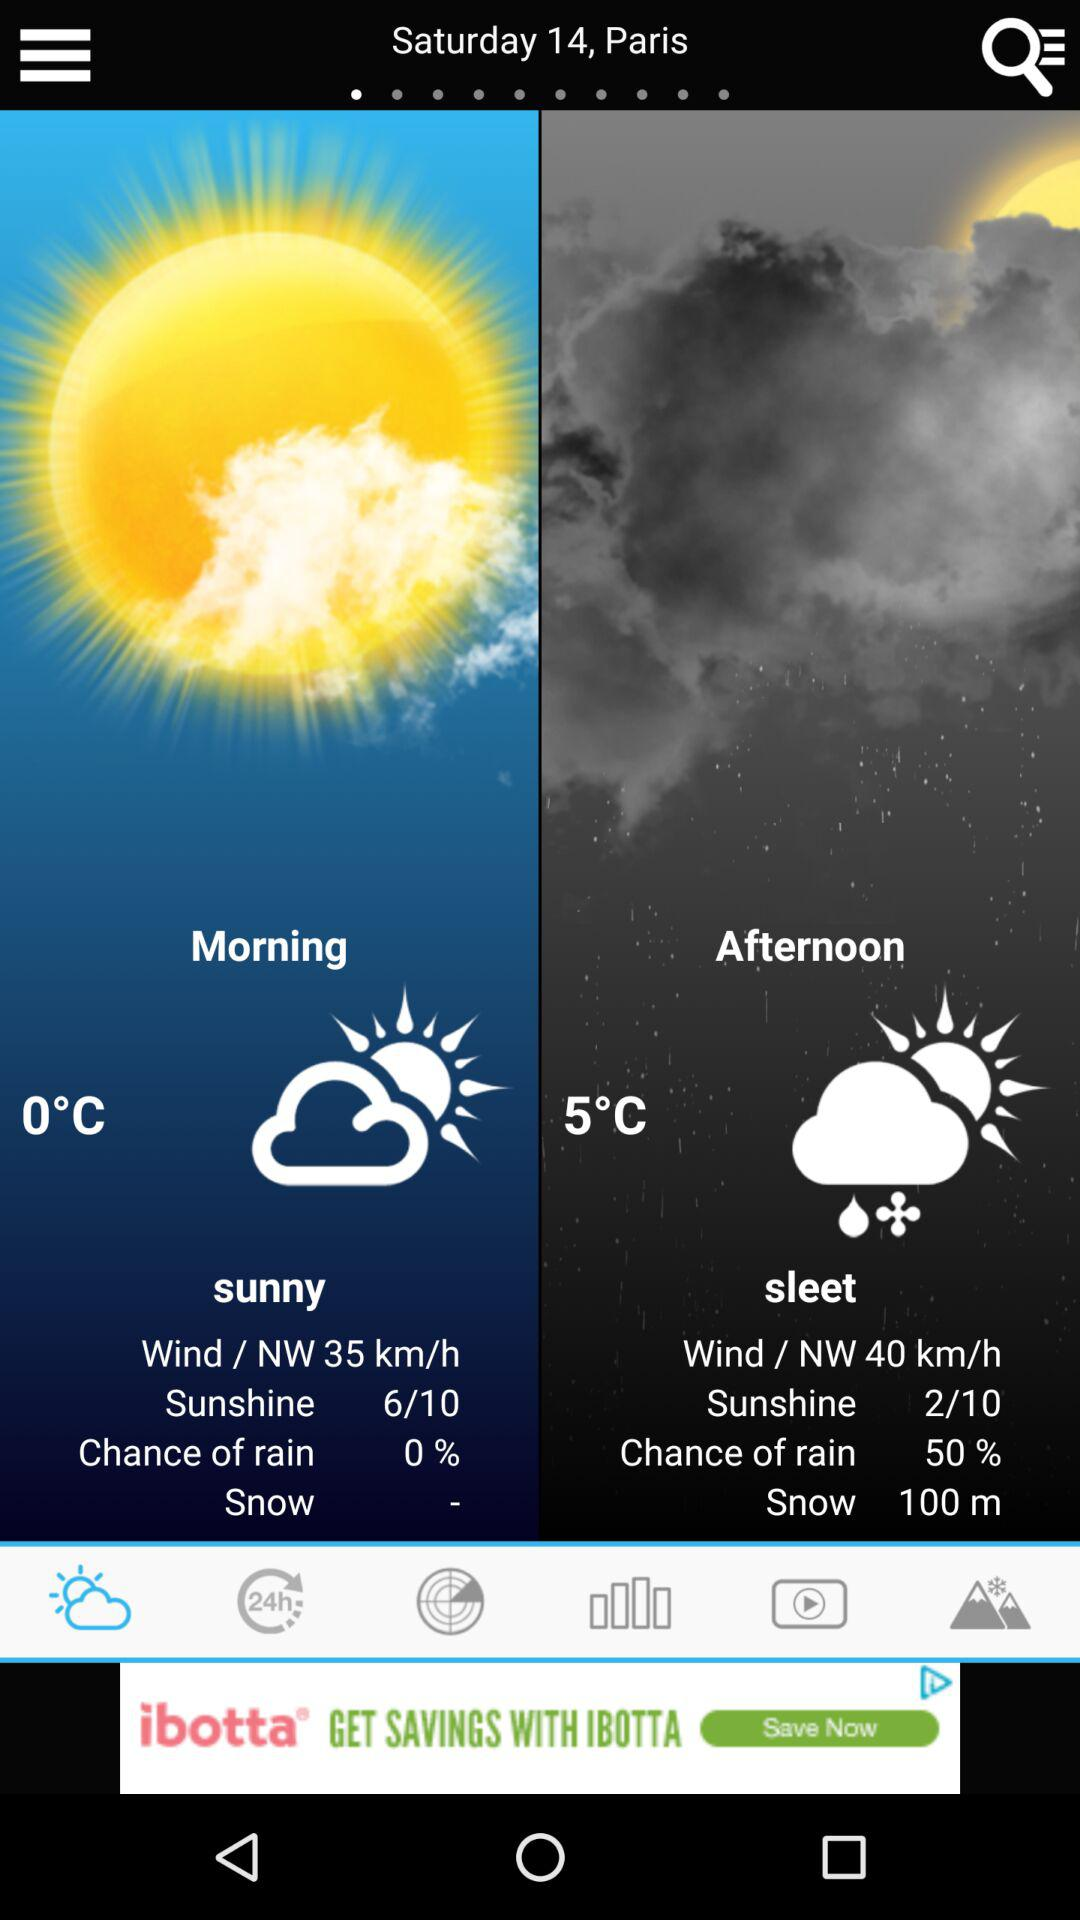What is the percentage chance of rain for the afternoon?
Answer the question using a single word or phrase. 50% 